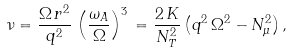<formula> <loc_0><loc_0><loc_500><loc_500>\nu = \frac { \Omega \, r ^ { 2 } } { q ^ { 2 } } \, \left ( \frac { \omega _ { A } } { \Omega } \right ) ^ { 3 } \, = \frac { 2 \, K } { N ^ { 2 } _ { T } } \, { \left ( q ^ { 2 } \, \Omega ^ { 2 } - N ^ { 2 } _ { \mu } \right ) } \, ,</formula> 